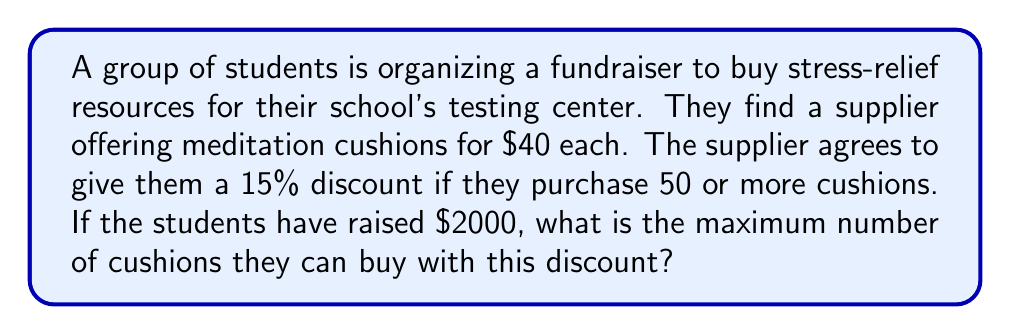Help me with this question. Let's approach this problem step by step:

1) First, we need to calculate the discounted price of each cushion:
   Original price: $40
   Discount: 15% = $40 \times 0.15 = $6
   
   Discounted price: $40 - $6 = $34

2) We can represent this calculation using the percentage formula:
   $$\text{Discounted price} = \text{Original price} \times (1 - \frac{\text{Discount percentage}}{100})$$
   $$= 40 \times (1 - \frac{15}{100}) = 40 \times 0.85 = $34$$

3) Now, we need to determine how many $34 cushions can be bought with $2000:
   $$\text{Number of cushions} = \frac{\text{Total money}}{\text{Price per cushion}}$$
   $$= \frac{2000}{34} \approx 58.82$$

4) Since we can't buy a fraction of a cushion, we round down to the nearest whole number:
   Maximum number of cushions = 58

5) We need to verify if this meets the condition for the discount (50 or more cushions). It does, so our calculation is correct.
Answer: The students can buy a maximum of 58 cushions with the discount. 